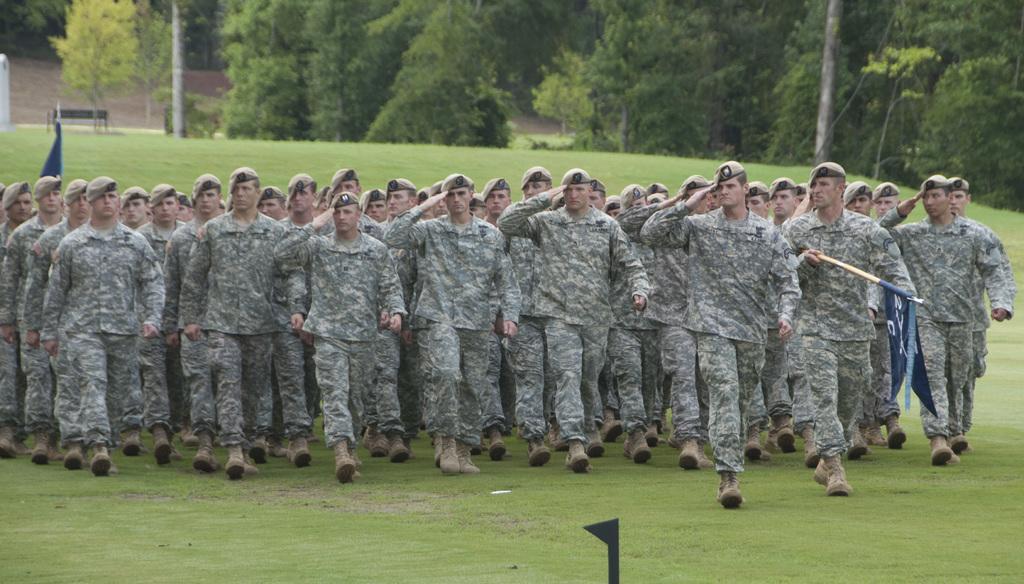Can you describe this image briefly? In the picture I can see some group of persons wearing camouflage dress, walking through the lawn and in the background of the picture there are some trees. 